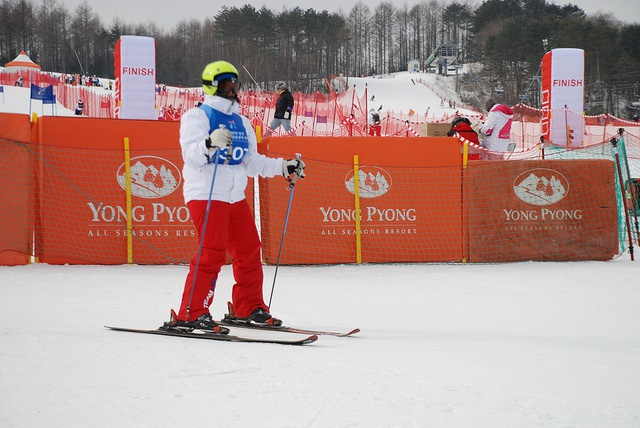Describe the objects in this image and their specific colors. I can see people in darkgray, brown, lightgray, and black tones, skis in darkgray, lightgray, gray, and black tones, people in darkgray, lightgray, and brown tones, people in darkgray, black, gray, and lightgray tones, and people in darkgray, brown, black, maroon, and gray tones in this image. 